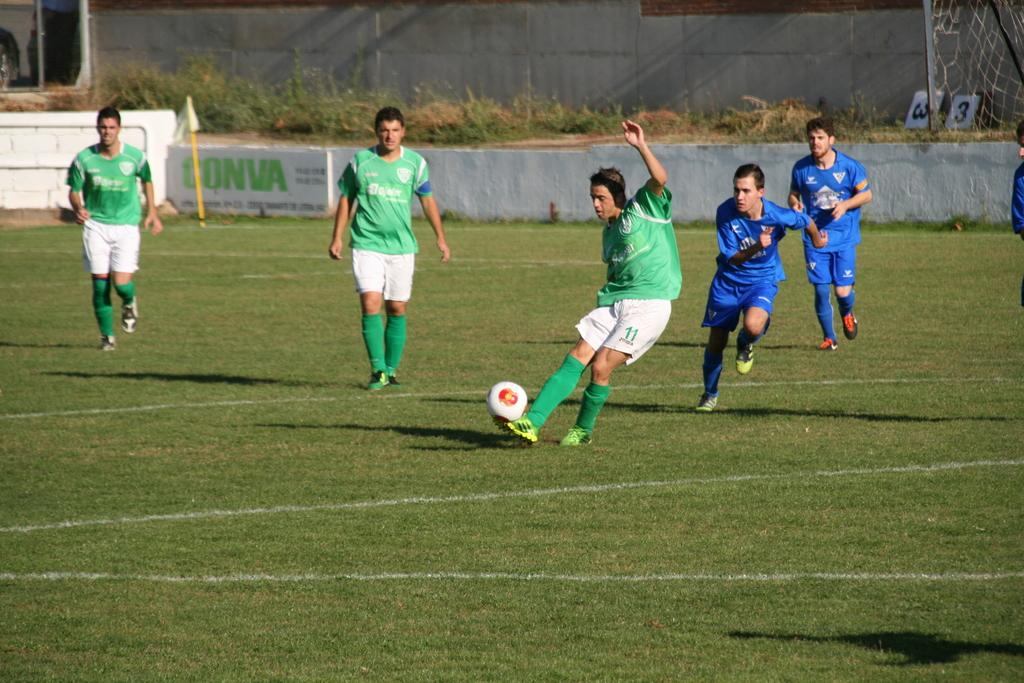How many people are in the image? There are people in the image, but the exact number is not specified. What object can be seen in the image that is typically used for playing games? There is a ball in the image. What type of vegetation is present in the image? There are plants in the image. What structure can be seen in the image that is typically used for displaying information or advertisements? There is a board in the image. What type of material can be seen in the image that is typically used for enclosing or separating spaces? There is a mesh in the image. What type of surface can be seen in the image that is typically used for writing or displaying information? There are boards in the image. What is the primary ground cover visible in the image? The land is covered with grass. Can you describe the relationship between a person and the ball in the image? A ball is near a person in the image. How does the cart help the person in the image? There is no mention of a cart in the image. 